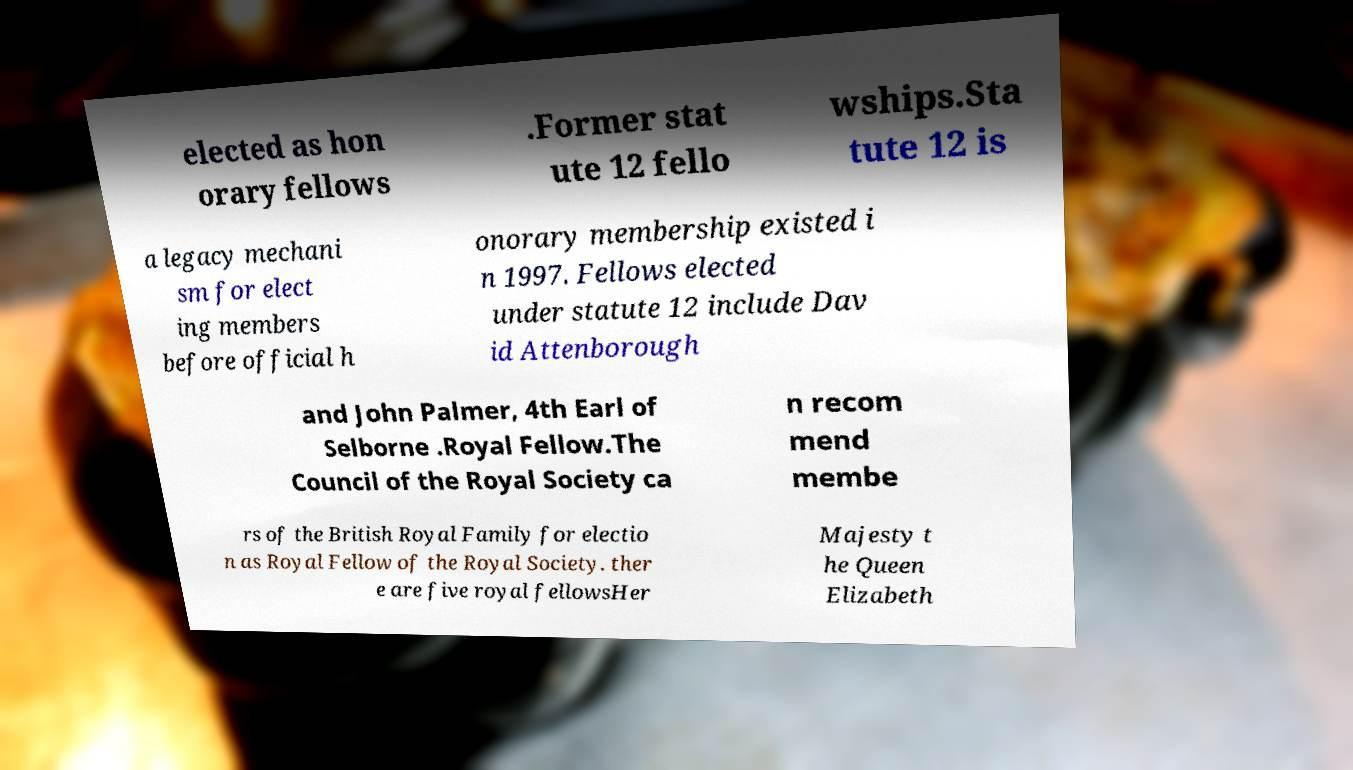Please read and relay the text visible in this image. What does it say? elected as hon orary fellows .Former stat ute 12 fello wships.Sta tute 12 is a legacy mechani sm for elect ing members before official h onorary membership existed i n 1997. Fellows elected under statute 12 include Dav id Attenborough and John Palmer, 4th Earl of Selborne .Royal Fellow.The Council of the Royal Society ca n recom mend membe rs of the British Royal Family for electio n as Royal Fellow of the Royal Society. ther e are five royal fellowsHer Majesty t he Queen Elizabeth 